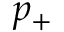<formula> <loc_0><loc_0><loc_500><loc_500>p _ { + }</formula> 